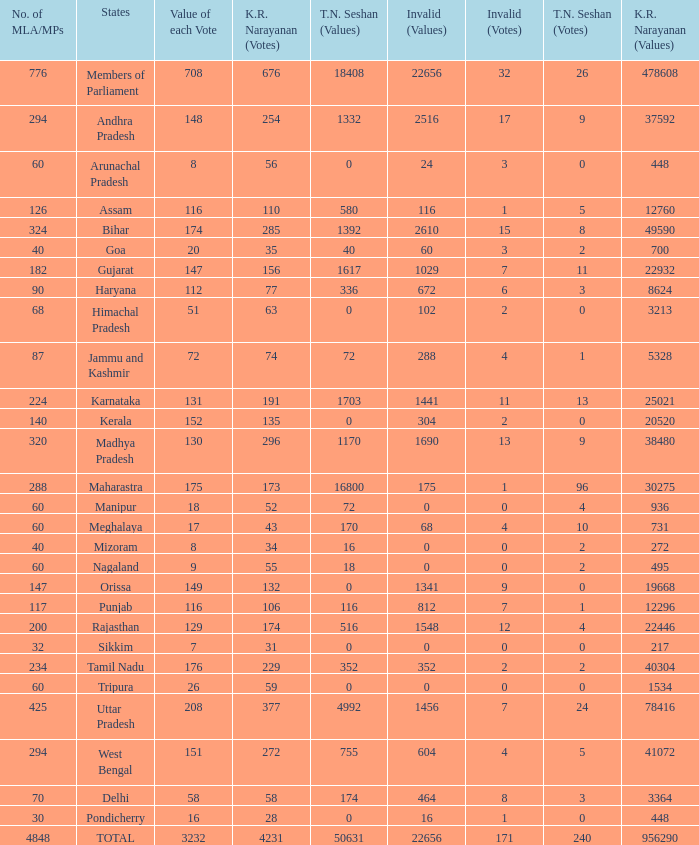Name the number of tn seshan values for kr values is 478608 1.0. 